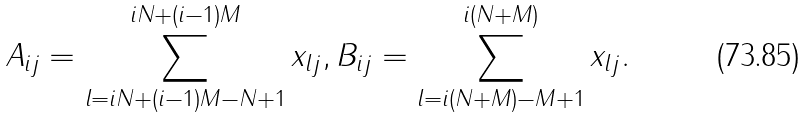Convert formula to latex. <formula><loc_0><loc_0><loc_500><loc_500>A _ { i j } = \sum ^ { i N + ( i - 1 ) M } _ { l = i N + ( i - 1 ) M - N + 1 } x _ { l j } , B _ { i j } = \sum ^ { i ( N + M ) } _ { l = i ( N + M ) - M + 1 } x _ { l j } .</formula> 